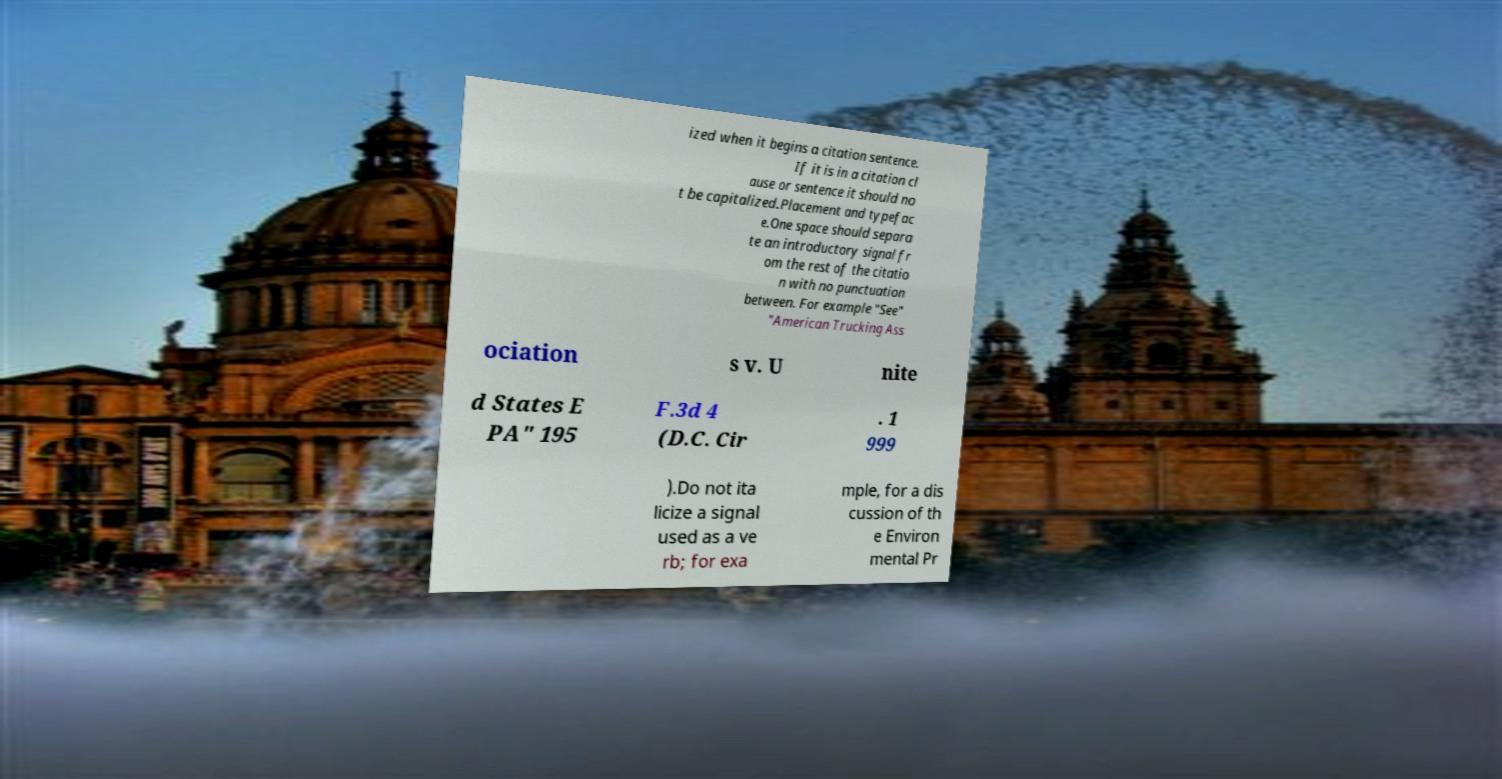Please identify and transcribe the text found in this image. ized when it begins a citation sentence. If it is in a citation cl ause or sentence it should no t be capitalized.Placement and typefac e.One space should separa te an introductory signal fr om the rest of the citatio n with no punctuation between. For example "See" "American Trucking Ass ociation s v. U nite d States E PA" 195 F.3d 4 (D.C. Cir . 1 999 ).Do not ita licize a signal used as a ve rb; for exa mple, for a dis cussion of th e Environ mental Pr 